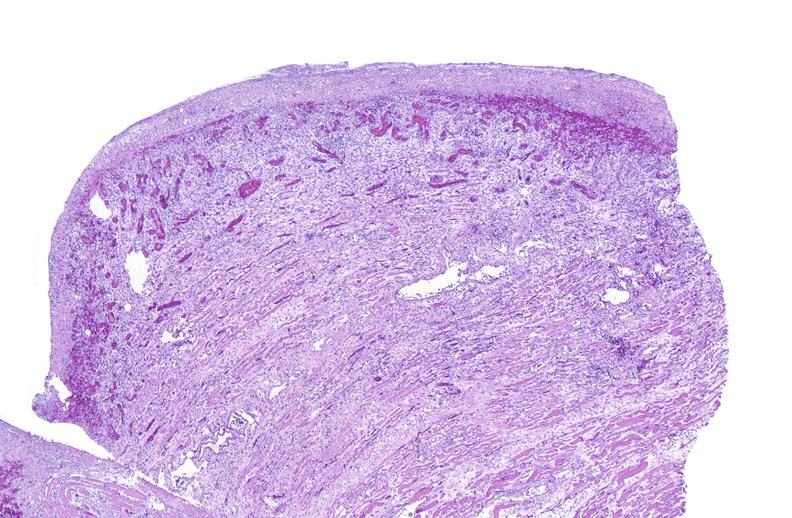does this image show tracheotomy, granulation tissue?
Answer the question using a single word or phrase. Yes 